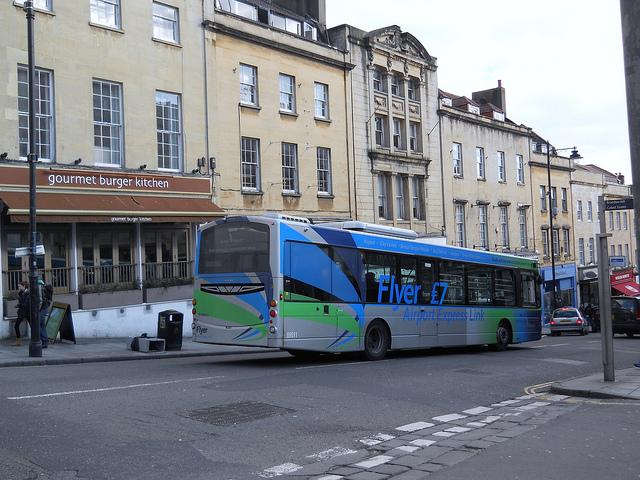What is the bus stopped outside of? restaurant 